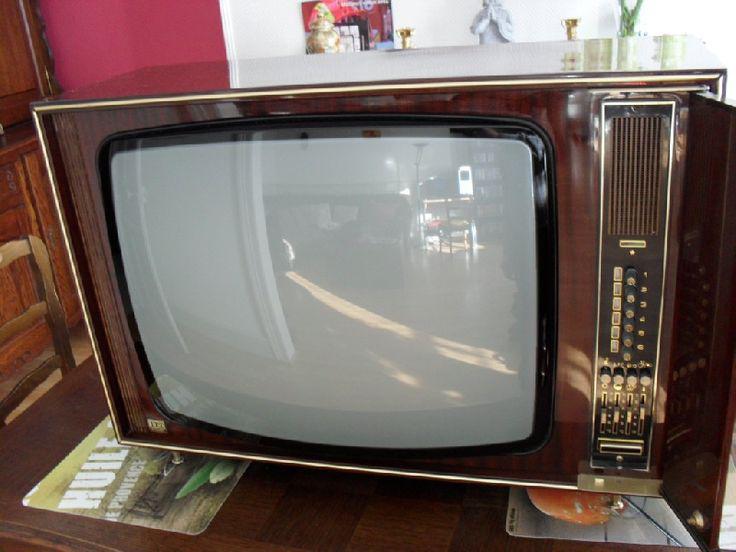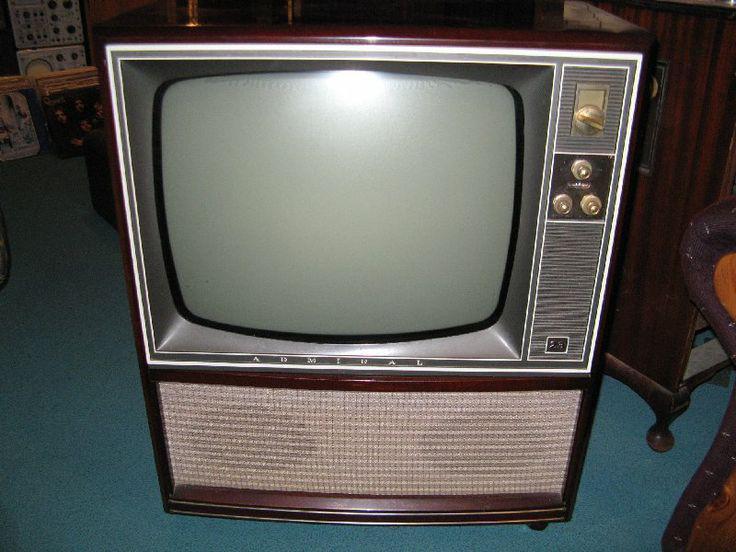The first image is the image on the left, the second image is the image on the right. Assess this claim about the two images: "The television in the image on the left has a woodgrain finish.". Correct or not? Answer yes or no. Yes. The first image is the image on the left, the second image is the image on the right. For the images shown, is this caption "Two televisions are shown, one a tabletop model, and the other in a wooden console cabinet on legs." true? Answer yes or no. No. 